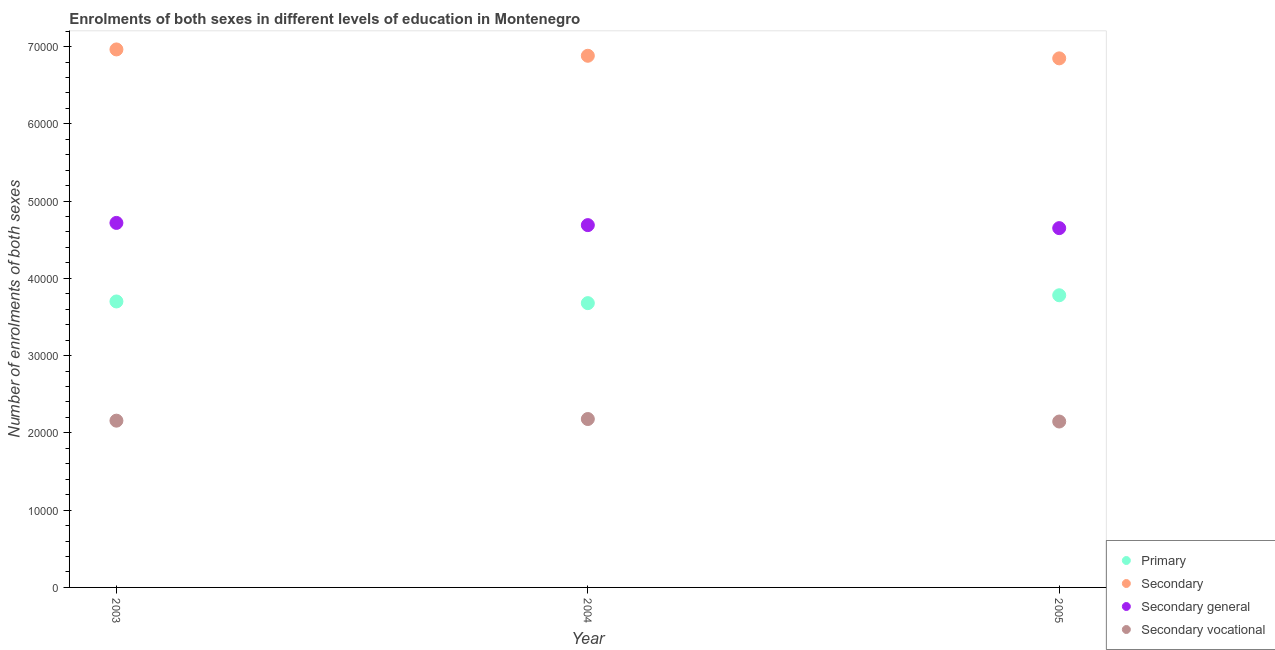Is the number of dotlines equal to the number of legend labels?
Offer a terse response. Yes. What is the number of enrolments in primary education in 2004?
Keep it short and to the point. 3.68e+04. Across all years, what is the maximum number of enrolments in secondary education?
Provide a succinct answer. 6.96e+04. Across all years, what is the minimum number of enrolments in secondary general education?
Your answer should be compact. 4.65e+04. In which year was the number of enrolments in secondary general education maximum?
Keep it short and to the point. 2003. In which year was the number of enrolments in secondary general education minimum?
Provide a short and direct response. 2005. What is the total number of enrolments in primary education in the graph?
Provide a succinct answer. 1.12e+05. What is the difference between the number of enrolments in primary education in 2003 and that in 2004?
Your answer should be very brief. 216. What is the difference between the number of enrolments in secondary general education in 2004 and the number of enrolments in secondary vocational education in 2005?
Ensure brevity in your answer.  2.54e+04. What is the average number of enrolments in primary education per year?
Your answer should be very brief. 3.72e+04. In the year 2004, what is the difference between the number of enrolments in primary education and number of enrolments in secondary vocational education?
Offer a terse response. 1.50e+04. What is the ratio of the number of enrolments in secondary education in 2003 to that in 2005?
Make the answer very short. 1.02. Is the number of enrolments in secondary education in 2003 less than that in 2005?
Offer a very short reply. No. What is the difference between the highest and the second highest number of enrolments in secondary vocational education?
Offer a terse response. 212. What is the difference between the highest and the lowest number of enrolments in primary education?
Provide a succinct answer. 1019. Is the sum of the number of enrolments in secondary general education in 2003 and 2004 greater than the maximum number of enrolments in primary education across all years?
Keep it short and to the point. Yes. Is it the case that in every year, the sum of the number of enrolments in secondary vocational education and number of enrolments in secondary education is greater than the sum of number of enrolments in secondary general education and number of enrolments in primary education?
Your response must be concise. No. Is it the case that in every year, the sum of the number of enrolments in primary education and number of enrolments in secondary education is greater than the number of enrolments in secondary general education?
Offer a terse response. Yes. Is the number of enrolments in primary education strictly greater than the number of enrolments in secondary general education over the years?
Provide a short and direct response. No. How many years are there in the graph?
Your response must be concise. 3. Are the values on the major ticks of Y-axis written in scientific E-notation?
Ensure brevity in your answer.  No. Does the graph contain any zero values?
Your answer should be compact. No. How are the legend labels stacked?
Your response must be concise. Vertical. What is the title of the graph?
Offer a very short reply. Enrolments of both sexes in different levels of education in Montenegro. Does "Primary" appear as one of the legend labels in the graph?
Provide a succinct answer. Yes. What is the label or title of the Y-axis?
Keep it short and to the point. Number of enrolments of both sexes. What is the Number of enrolments of both sexes in Primary in 2003?
Ensure brevity in your answer.  3.70e+04. What is the Number of enrolments of both sexes of Secondary in 2003?
Make the answer very short. 6.96e+04. What is the Number of enrolments of both sexes of Secondary general in 2003?
Your answer should be very brief. 4.72e+04. What is the Number of enrolments of both sexes in Secondary vocational in 2003?
Offer a terse response. 2.16e+04. What is the Number of enrolments of both sexes in Primary in 2004?
Give a very brief answer. 3.68e+04. What is the Number of enrolments of both sexes of Secondary in 2004?
Your answer should be very brief. 6.88e+04. What is the Number of enrolments of both sexes of Secondary general in 2004?
Your answer should be compact. 4.69e+04. What is the Number of enrolments of both sexes in Secondary vocational in 2004?
Your answer should be compact. 2.18e+04. What is the Number of enrolments of both sexes of Primary in 2005?
Make the answer very short. 3.78e+04. What is the Number of enrolments of both sexes of Secondary in 2005?
Ensure brevity in your answer.  6.85e+04. What is the Number of enrolments of both sexes in Secondary general in 2005?
Provide a short and direct response. 4.65e+04. What is the Number of enrolments of both sexes of Secondary vocational in 2005?
Ensure brevity in your answer.  2.15e+04. Across all years, what is the maximum Number of enrolments of both sexes in Primary?
Ensure brevity in your answer.  3.78e+04. Across all years, what is the maximum Number of enrolments of both sexes of Secondary?
Ensure brevity in your answer.  6.96e+04. Across all years, what is the maximum Number of enrolments of both sexes in Secondary general?
Provide a succinct answer. 4.72e+04. Across all years, what is the maximum Number of enrolments of both sexes in Secondary vocational?
Your answer should be very brief. 2.18e+04. Across all years, what is the minimum Number of enrolments of both sexes of Primary?
Offer a terse response. 3.68e+04. Across all years, what is the minimum Number of enrolments of both sexes of Secondary?
Ensure brevity in your answer.  6.85e+04. Across all years, what is the minimum Number of enrolments of both sexes of Secondary general?
Provide a short and direct response. 4.65e+04. Across all years, what is the minimum Number of enrolments of both sexes of Secondary vocational?
Provide a succinct answer. 2.15e+04. What is the total Number of enrolments of both sexes in Primary in the graph?
Offer a very short reply. 1.12e+05. What is the total Number of enrolments of both sexes of Secondary in the graph?
Keep it short and to the point. 2.07e+05. What is the total Number of enrolments of both sexes of Secondary general in the graph?
Make the answer very short. 1.41e+05. What is the total Number of enrolments of both sexes of Secondary vocational in the graph?
Ensure brevity in your answer.  6.48e+04. What is the difference between the Number of enrolments of both sexes in Primary in 2003 and that in 2004?
Make the answer very short. 216. What is the difference between the Number of enrolments of both sexes in Secondary in 2003 and that in 2004?
Provide a short and direct response. 820. What is the difference between the Number of enrolments of both sexes of Secondary general in 2003 and that in 2004?
Your answer should be very brief. 286. What is the difference between the Number of enrolments of both sexes of Secondary vocational in 2003 and that in 2004?
Make the answer very short. -212. What is the difference between the Number of enrolments of both sexes of Primary in 2003 and that in 2005?
Make the answer very short. -803. What is the difference between the Number of enrolments of both sexes in Secondary in 2003 and that in 2005?
Offer a very short reply. 1156. What is the difference between the Number of enrolments of both sexes in Secondary general in 2003 and that in 2005?
Provide a short and direct response. 675. What is the difference between the Number of enrolments of both sexes in Secondary vocational in 2003 and that in 2005?
Offer a terse response. 111. What is the difference between the Number of enrolments of both sexes of Primary in 2004 and that in 2005?
Offer a terse response. -1019. What is the difference between the Number of enrolments of both sexes in Secondary in 2004 and that in 2005?
Your answer should be very brief. 336. What is the difference between the Number of enrolments of both sexes of Secondary general in 2004 and that in 2005?
Offer a very short reply. 389. What is the difference between the Number of enrolments of both sexes in Secondary vocational in 2004 and that in 2005?
Offer a terse response. 323. What is the difference between the Number of enrolments of both sexes of Primary in 2003 and the Number of enrolments of both sexes of Secondary in 2004?
Give a very brief answer. -3.18e+04. What is the difference between the Number of enrolments of both sexes of Primary in 2003 and the Number of enrolments of both sexes of Secondary general in 2004?
Provide a succinct answer. -9880. What is the difference between the Number of enrolments of both sexes in Primary in 2003 and the Number of enrolments of both sexes in Secondary vocational in 2004?
Your response must be concise. 1.52e+04. What is the difference between the Number of enrolments of both sexes of Secondary in 2003 and the Number of enrolments of both sexes of Secondary general in 2004?
Your answer should be very brief. 2.27e+04. What is the difference between the Number of enrolments of both sexes of Secondary in 2003 and the Number of enrolments of both sexes of Secondary vocational in 2004?
Give a very brief answer. 4.78e+04. What is the difference between the Number of enrolments of both sexes in Secondary general in 2003 and the Number of enrolments of both sexes in Secondary vocational in 2004?
Offer a terse response. 2.54e+04. What is the difference between the Number of enrolments of both sexes of Primary in 2003 and the Number of enrolments of both sexes of Secondary in 2005?
Provide a succinct answer. -3.15e+04. What is the difference between the Number of enrolments of both sexes in Primary in 2003 and the Number of enrolments of both sexes in Secondary general in 2005?
Make the answer very short. -9491. What is the difference between the Number of enrolments of both sexes in Primary in 2003 and the Number of enrolments of both sexes in Secondary vocational in 2005?
Your response must be concise. 1.55e+04. What is the difference between the Number of enrolments of both sexes in Secondary in 2003 and the Number of enrolments of both sexes in Secondary general in 2005?
Provide a succinct answer. 2.31e+04. What is the difference between the Number of enrolments of both sexes in Secondary in 2003 and the Number of enrolments of both sexes in Secondary vocational in 2005?
Ensure brevity in your answer.  4.82e+04. What is the difference between the Number of enrolments of both sexes of Secondary general in 2003 and the Number of enrolments of both sexes of Secondary vocational in 2005?
Keep it short and to the point. 2.57e+04. What is the difference between the Number of enrolments of both sexes in Primary in 2004 and the Number of enrolments of both sexes in Secondary in 2005?
Provide a short and direct response. -3.17e+04. What is the difference between the Number of enrolments of both sexes in Primary in 2004 and the Number of enrolments of both sexes in Secondary general in 2005?
Your response must be concise. -9707. What is the difference between the Number of enrolments of both sexes of Primary in 2004 and the Number of enrolments of both sexes of Secondary vocational in 2005?
Ensure brevity in your answer.  1.53e+04. What is the difference between the Number of enrolments of both sexes of Secondary in 2004 and the Number of enrolments of both sexes of Secondary general in 2005?
Keep it short and to the point. 2.23e+04. What is the difference between the Number of enrolments of both sexes in Secondary in 2004 and the Number of enrolments of both sexes in Secondary vocational in 2005?
Provide a short and direct response. 4.73e+04. What is the difference between the Number of enrolments of both sexes of Secondary general in 2004 and the Number of enrolments of both sexes of Secondary vocational in 2005?
Your answer should be compact. 2.54e+04. What is the average Number of enrolments of both sexes in Primary per year?
Your answer should be compact. 3.72e+04. What is the average Number of enrolments of both sexes of Secondary per year?
Provide a succinct answer. 6.90e+04. What is the average Number of enrolments of both sexes of Secondary general per year?
Offer a very short reply. 4.69e+04. What is the average Number of enrolments of both sexes in Secondary vocational per year?
Provide a short and direct response. 2.16e+04. In the year 2003, what is the difference between the Number of enrolments of both sexes in Primary and Number of enrolments of both sexes in Secondary?
Make the answer very short. -3.26e+04. In the year 2003, what is the difference between the Number of enrolments of both sexes in Primary and Number of enrolments of both sexes in Secondary general?
Give a very brief answer. -1.02e+04. In the year 2003, what is the difference between the Number of enrolments of both sexes in Primary and Number of enrolments of both sexes in Secondary vocational?
Provide a short and direct response. 1.54e+04. In the year 2003, what is the difference between the Number of enrolments of both sexes in Secondary and Number of enrolments of both sexes in Secondary general?
Make the answer very short. 2.25e+04. In the year 2003, what is the difference between the Number of enrolments of both sexes in Secondary and Number of enrolments of both sexes in Secondary vocational?
Give a very brief answer. 4.80e+04. In the year 2003, what is the difference between the Number of enrolments of both sexes in Secondary general and Number of enrolments of both sexes in Secondary vocational?
Keep it short and to the point. 2.56e+04. In the year 2004, what is the difference between the Number of enrolments of both sexes in Primary and Number of enrolments of both sexes in Secondary?
Give a very brief answer. -3.20e+04. In the year 2004, what is the difference between the Number of enrolments of both sexes in Primary and Number of enrolments of both sexes in Secondary general?
Offer a terse response. -1.01e+04. In the year 2004, what is the difference between the Number of enrolments of both sexes in Primary and Number of enrolments of both sexes in Secondary vocational?
Offer a very short reply. 1.50e+04. In the year 2004, what is the difference between the Number of enrolments of both sexes in Secondary and Number of enrolments of both sexes in Secondary general?
Provide a short and direct response. 2.19e+04. In the year 2004, what is the difference between the Number of enrolments of both sexes in Secondary and Number of enrolments of both sexes in Secondary vocational?
Provide a succinct answer. 4.70e+04. In the year 2004, what is the difference between the Number of enrolments of both sexes of Secondary general and Number of enrolments of both sexes of Secondary vocational?
Your answer should be very brief. 2.51e+04. In the year 2005, what is the difference between the Number of enrolments of both sexes in Primary and Number of enrolments of both sexes in Secondary?
Keep it short and to the point. -3.07e+04. In the year 2005, what is the difference between the Number of enrolments of both sexes in Primary and Number of enrolments of both sexes in Secondary general?
Give a very brief answer. -8688. In the year 2005, what is the difference between the Number of enrolments of both sexes in Primary and Number of enrolments of both sexes in Secondary vocational?
Offer a very short reply. 1.63e+04. In the year 2005, what is the difference between the Number of enrolments of both sexes in Secondary and Number of enrolments of both sexes in Secondary general?
Offer a terse response. 2.20e+04. In the year 2005, what is the difference between the Number of enrolments of both sexes of Secondary and Number of enrolments of both sexes of Secondary vocational?
Ensure brevity in your answer.  4.70e+04. In the year 2005, what is the difference between the Number of enrolments of both sexes of Secondary general and Number of enrolments of both sexes of Secondary vocational?
Provide a short and direct response. 2.50e+04. What is the ratio of the Number of enrolments of both sexes in Primary in 2003 to that in 2004?
Provide a short and direct response. 1.01. What is the ratio of the Number of enrolments of both sexes in Secondary in 2003 to that in 2004?
Offer a terse response. 1.01. What is the ratio of the Number of enrolments of both sexes in Secondary general in 2003 to that in 2004?
Ensure brevity in your answer.  1.01. What is the ratio of the Number of enrolments of both sexes of Secondary vocational in 2003 to that in 2004?
Offer a very short reply. 0.99. What is the ratio of the Number of enrolments of both sexes in Primary in 2003 to that in 2005?
Make the answer very short. 0.98. What is the ratio of the Number of enrolments of both sexes of Secondary in 2003 to that in 2005?
Ensure brevity in your answer.  1.02. What is the ratio of the Number of enrolments of both sexes in Secondary general in 2003 to that in 2005?
Make the answer very short. 1.01. What is the ratio of the Number of enrolments of both sexes in Primary in 2004 to that in 2005?
Give a very brief answer. 0.97. What is the ratio of the Number of enrolments of both sexes of Secondary in 2004 to that in 2005?
Make the answer very short. 1. What is the ratio of the Number of enrolments of both sexes of Secondary general in 2004 to that in 2005?
Make the answer very short. 1.01. What is the ratio of the Number of enrolments of both sexes of Secondary vocational in 2004 to that in 2005?
Make the answer very short. 1.01. What is the difference between the highest and the second highest Number of enrolments of both sexes of Primary?
Your answer should be compact. 803. What is the difference between the highest and the second highest Number of enrolments of both sexes in Secondary?
Your answer should be very brief. 820. What is the difference between the highest and the second highest Number of enrolments of both sexes of Secondary general?
Your response must be concise. 286. What is the difference between the highest and the second highest Number of enrolments of both sexes in Secondary vocational?
Provide a succinct answer. 212. What is the difference between the highest and the lowest Number of enrolments of both sexes in Primary?
Give a very brief answer. 1019. What is the difference between the highest and the lowest Number of enrolments of both sexes of Secondary?
Your answer should be compact. 1156. What is the difference between the highest and the lowest Number of enrolments of both sexes of Secondary general?
Give a very brief answer. 675. What is the difference between the highest and the lowest Number of enrolments of both sexes of Secondary vocational?
Make the answer very short. 323. 